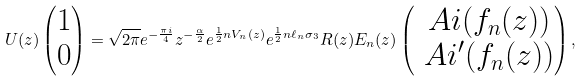<formula> <loc_0><loc_0><loc_500><loc_500>U ( z ) \begin{pmatrix} 1 \\ 0 \end{pmatrix} = \sqrt { 2 \pi } e ^ { - \frac { \pi i } { 4 } } z ^ { - \frac { \alpha } { 2 } } e ^ { \frac { 1 } { 2 } n V _ { n } ( z ) } e ^ { \frac { 1 } { 2 } n \ell _ { n } \sigma _ { 3 } } R ( z ) E _ { n } ( z ) \begin{pmatrix} \ A i ( f _ { n } ( z ) ) \\ \ A i ^ { \prime } ( f _ { n } ( z ) ) \end{pmatrix} ,</formula> 